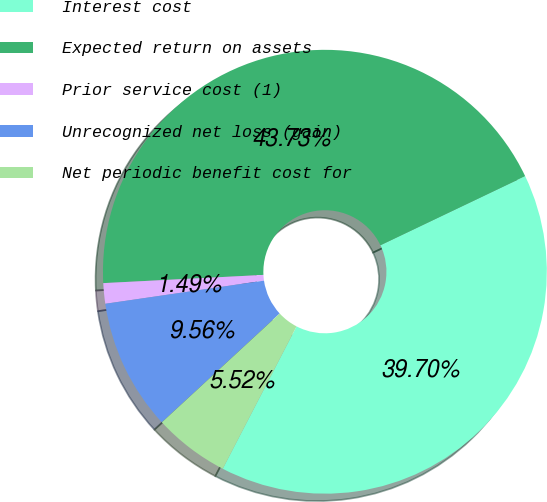Convert chart to OTSL. <chart><loc_0><loc_0><loc_500><loc_500><pie_chart><fcel>Interest cost<fcel>Expected return on assets<fcel>Prior service cost (1)<fcel>Unrecognized net loss (gain)<fcel>Net periodic benefit cost for<nl><fcel>39.7%<fcel>43.73%<fcel>1.49%<fcel>9.56%<fcel>5.52%<nl></chart> 